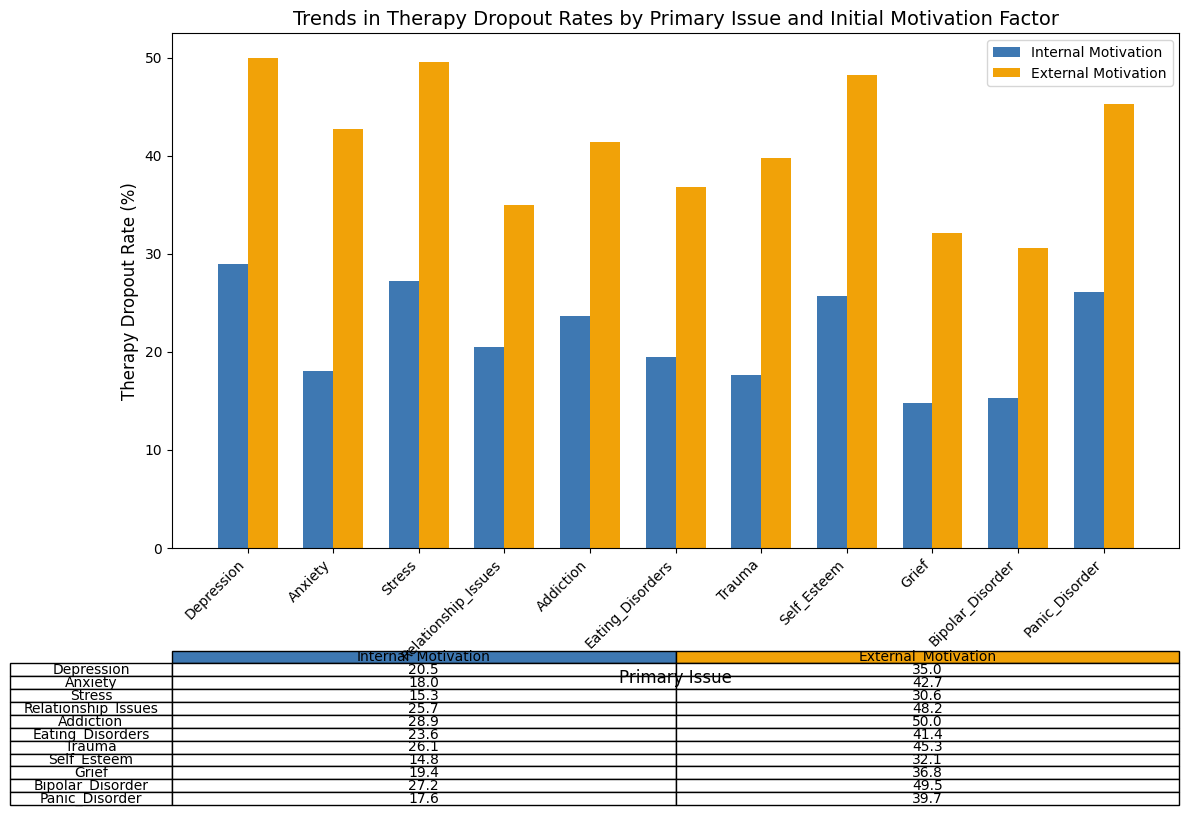Which primary issue has the highest therapy dropout rate overall? The highest dropout rate can be determined by comparing all the rates presented in the plot for both internal and external motivations. The highest rate is for cases of Addiction with external motivation at 50.0%.
Answer: Addiction What is the difference in therapy dropout rates between internal and external motivation for Anxiety? Subtract the dropout rate for internal motivation from that for external motivation. For Anxiety, it's 42.7 - 18.0 = 24.7%.
Answer: 24.7% Which primary issue shows the smallest difference in dropout rates between internal and external motivations? The smallest difference is found by comparing the differences for each issue. For Self Esteem, the difference is 32.1 - 14.8 = 17.3%, which appears to be the smallest.
Answer: Self Esteem What is the average dropout rate for issues with internal motivation? Sum the dropout rates for all issues with internal motivation and divide by the number of issues. (20.5 + 18.0 + 15.3 + 25.7 + 28.9 + 23.6 + 26.1 + 14.8 + 19.4 + 27.2 + 17.6) / 11 ≈ 21.1%.
Answer: 21.1% For which primary issue does external motivation have a therapy dropout rate below 40%? Identify the dropout rates for external motivation that are below 40%. Grief with a rate of 36.8% is the only issue below this threshold.
Answer: Grief Compare the therapy dropout rates for internal motivation for Depression and Stress. Which one is higher? Compare the two rates directly: Depression has a rate of 20.5% and Stress has a rate of 15.3%. Depression is higher.
Answer: Depression What is the combined therapy dropout rate for Trauma, considering both internal and external motivations? Add the dropout rates for both internal and external motivations. For Trauma, it's 26.1 + 45.3 = 71.4%.
Answer: 71.4% Which primary issue has a lower therapy dropout rate for internal motivation compared to the external motivation dropout rate for Stress? Compare internal motivation rates to the external motivation rate for Stress (30.6%). Rates lower than 30.6% are for Depression (20.5%), Anxiety (18.0%), Stress (15.3%), Relationship Issues (25.7%), Eating Disorders (23.6%), Self Esteem (14.8%), Grief (19.4%), and Panic Disorder (17.6%).
Answer: Multiple issues What pattern do you observe in dropout rates between internal versus external motivation? Compare the bars for internal and external motivations across all issues. Generally, therapy dropout rates are higher for external motivations compared to internal motivations. For every issue, the rate for external motivation is greater than that for internal motivation.
Answer: External > Internal 